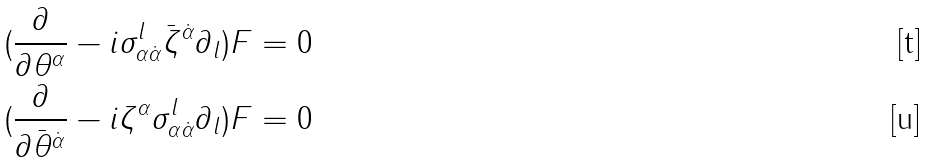<formula> <loc_0><loc_0><loc_500><loc_500>( \frac { \partial } { \partial \theta ^ { \alpha } } - i \sigma _ { \alpha \dot { \alpha } } ^ { l } \bar { \zeta } ^ { \dot { \alpha } } \partial _ { l } ) F = 0 \\ ( \frac { \partial } { \partial \bar { \theta } ^ { \dot { \alpha } } } - i \zeta ^ { \alpha } \sigma _ { \alpha \dot { \alpha } } ^ { l } \partial _ { l } ) F = 0</formula> 